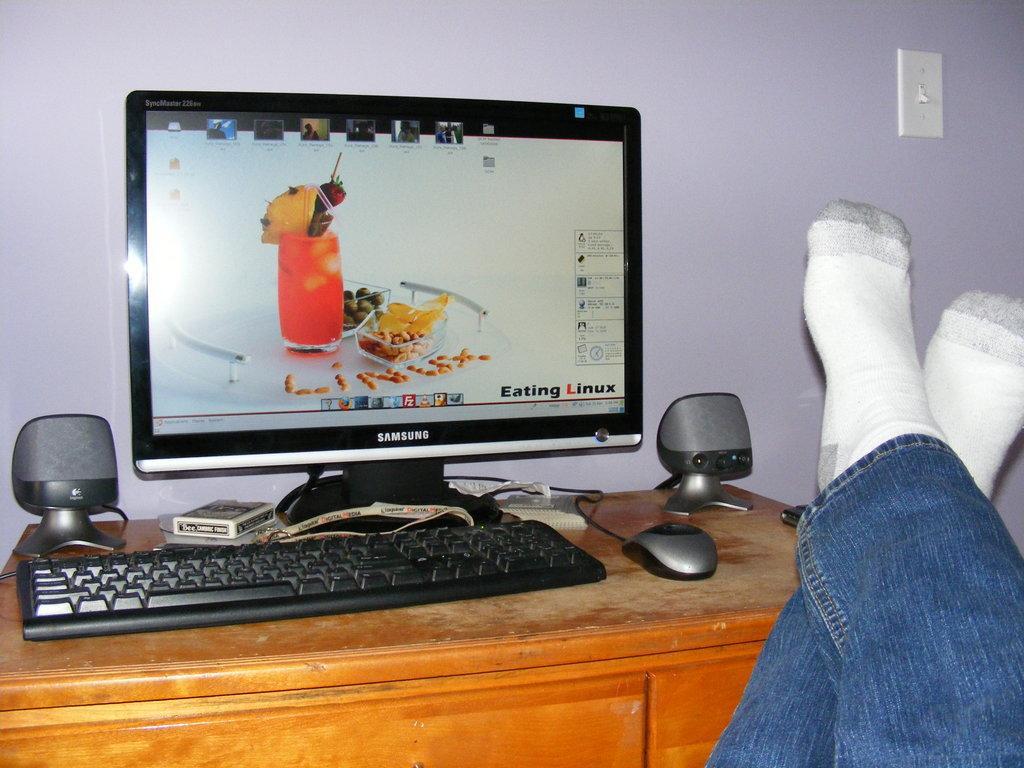Describe this image in one or two sentences. On this table there is a box, speakers, mouse, keyboard and monitor. These are legs with socks. 